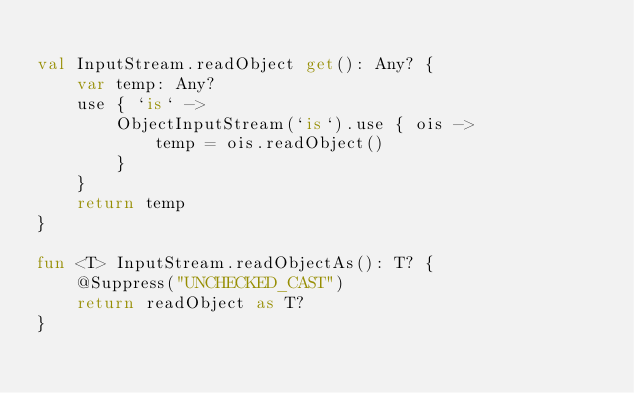Convert code to text. <code><loc_0><loc_0><loc_500><loc_500><_Kotlin_>
val InputStream.readObject get(): Any? {
    var temp: Any?
    use { `is` ->
        ObjectInputStream(`is`).use { ois ->
            temp = ois.readObject()
        }
    }
    return temp
}

fun <T> InputStream.readObjectAs(): T? {
    @Suppress("UNCHECKED_CAST")
    return readObject as T?
}</code> 